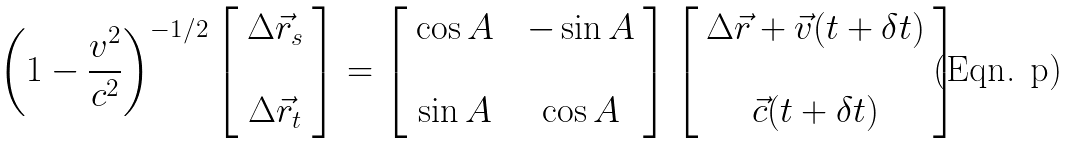<formula> <loc_0><loc_0><loc_500><loc_500>\left ( 1 - \frac { v ^ { 2 } } { c ^ { 2 } } \right ) ^ { - 1 / 2 } \left [ \begin{array} { c c c } \Delta \vec { r } _ { s } \\ \\ \Delta \vec { r } _ { t } \end{array} \right ] = \left [ \begin{array} { c c c } \cos A & & - \sin A \\ \\ \sin A & & \cos A \end{array} \right ] \left [ \begin{array} { c c c } \Delta \vec { r } + \vec { v } ( t + \delta t ) \\ \\ \vec { c } ( t + \delta t ) \end{array} \right ]</formula> 